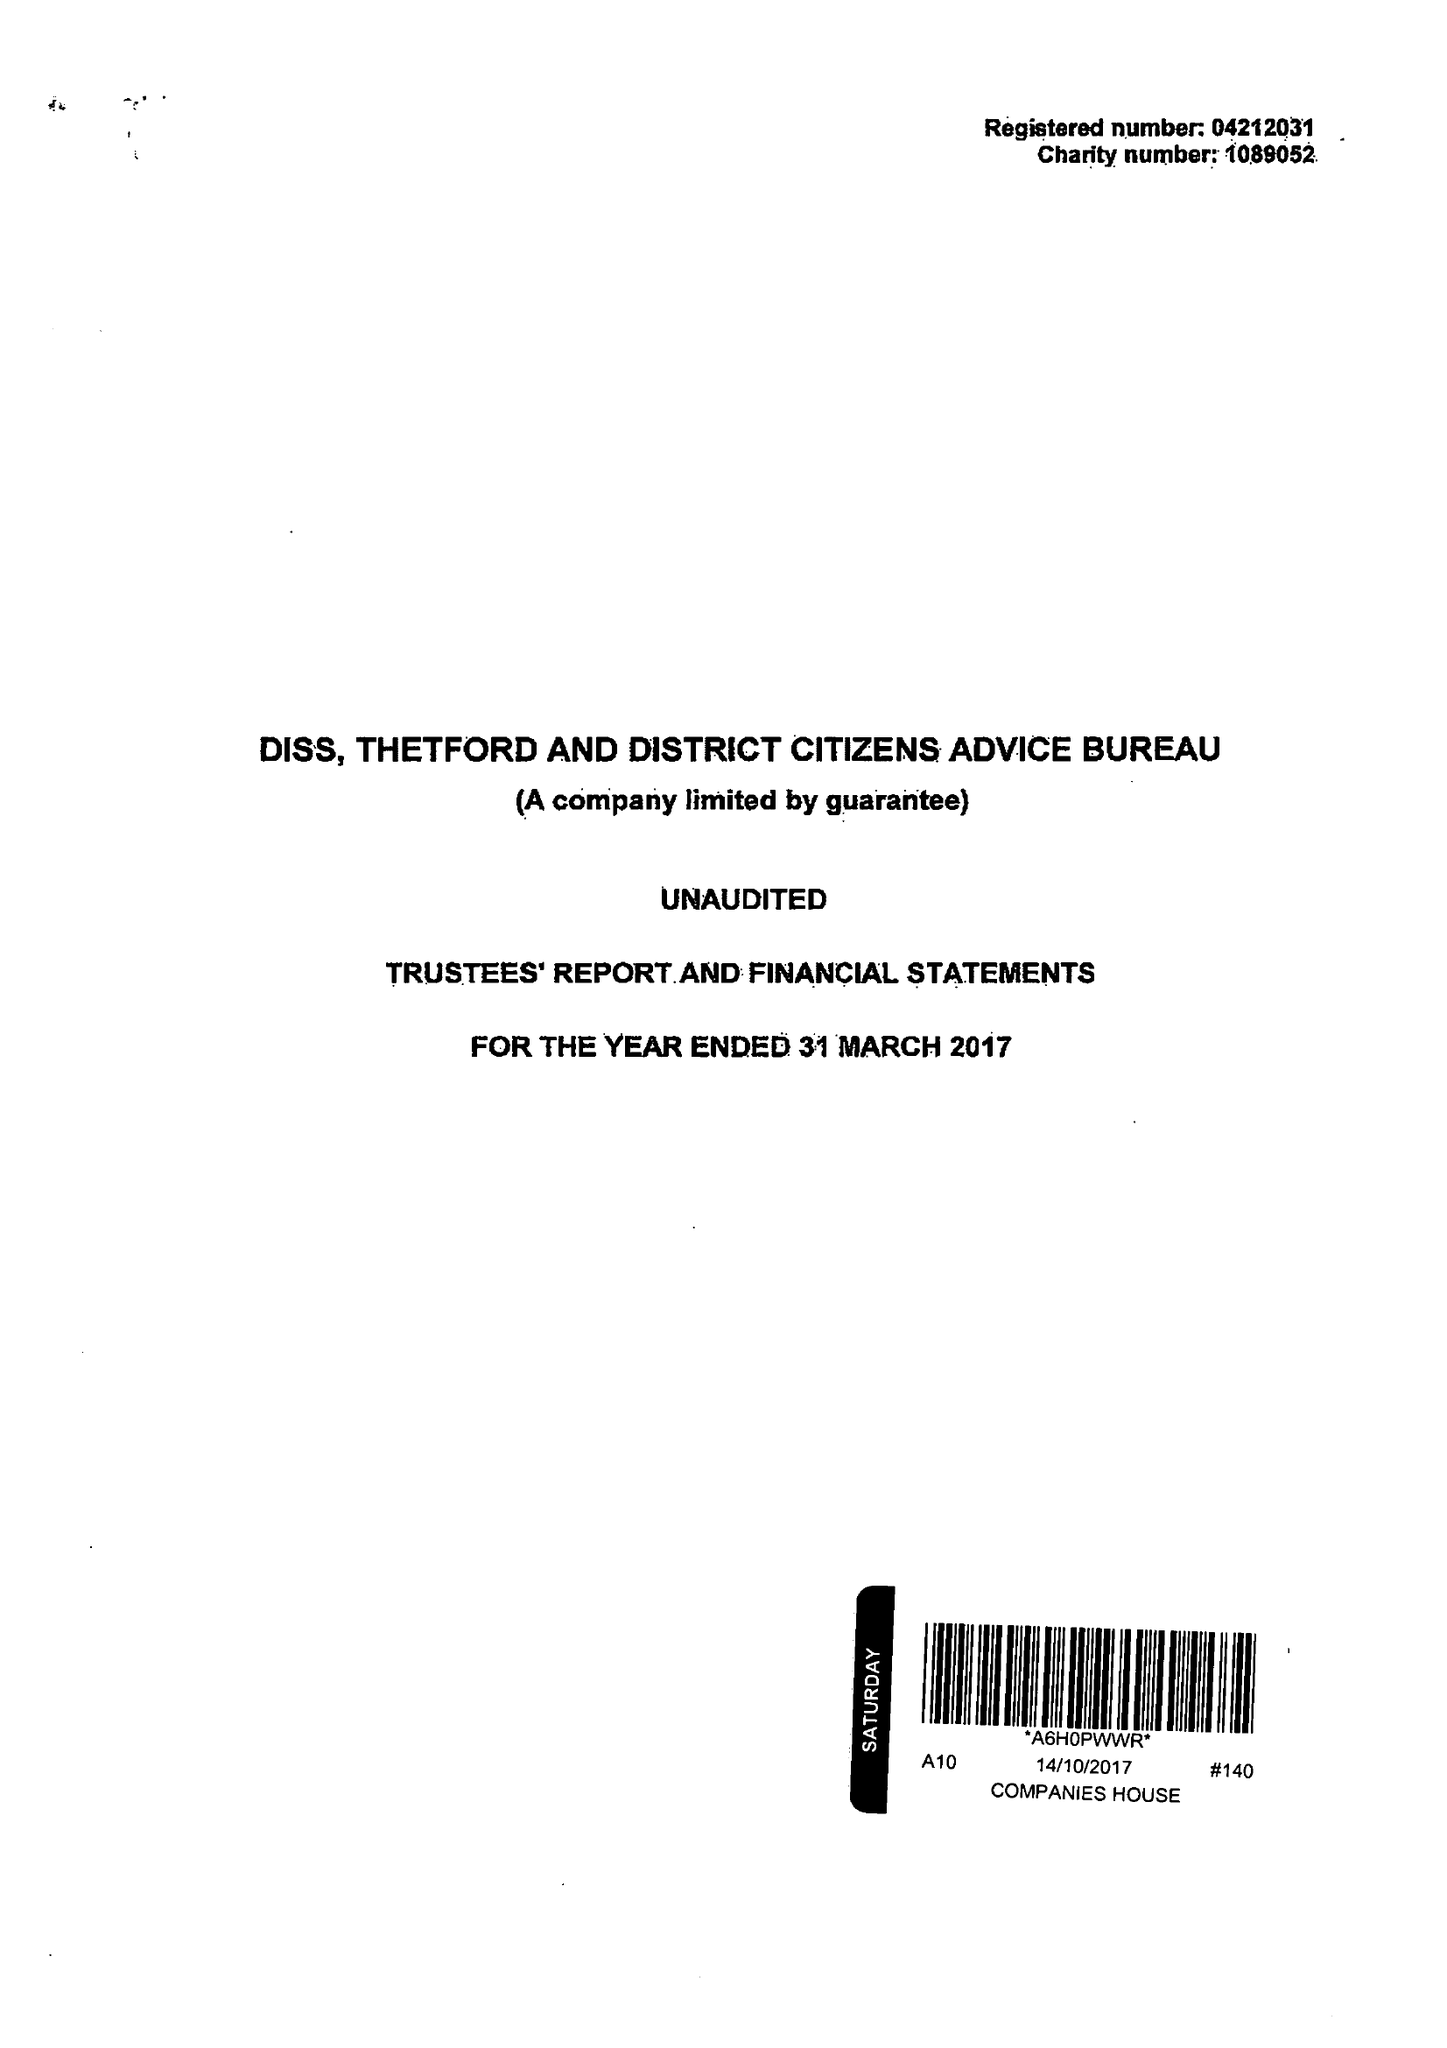What is the value for the income_annually_in_british_pounds?
Answer the question using a single word or phrase. 378010.00 